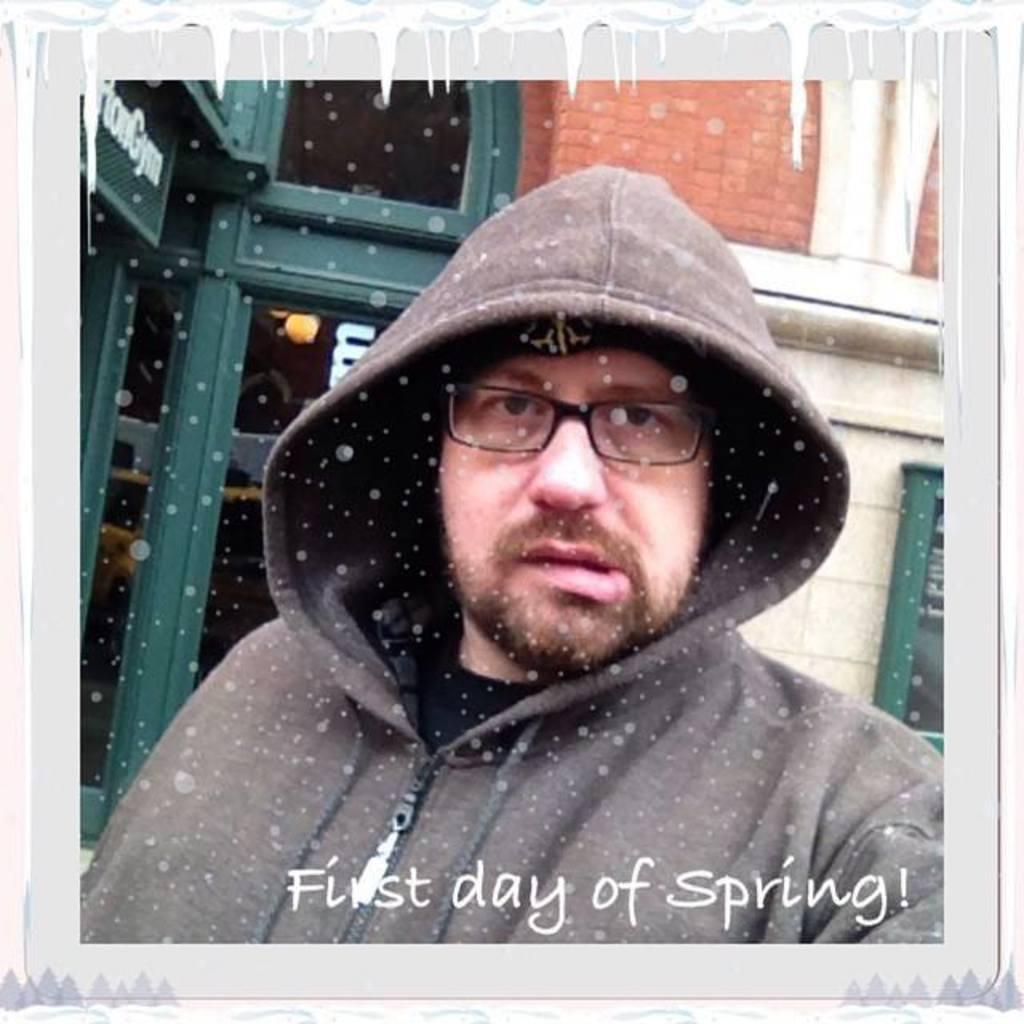What object is present in the image that typically holds a photograph? There is a photo frame in the image. What can be seen inside the photo frame? The photo frame contains a person. Can you describe the person in the photo frame? The person in the photo frame is wearing spectacles. What else is visible in the photo frame besides the person? There is text visible in the photo frame. What can be seen in the background of the image? There is a building and a wall in the background of the image. How many spiders are crawling on the person in the photo frame? There are no spiders visible in the image, as it only shows a photo frame with a person wearing spectacles and text. 